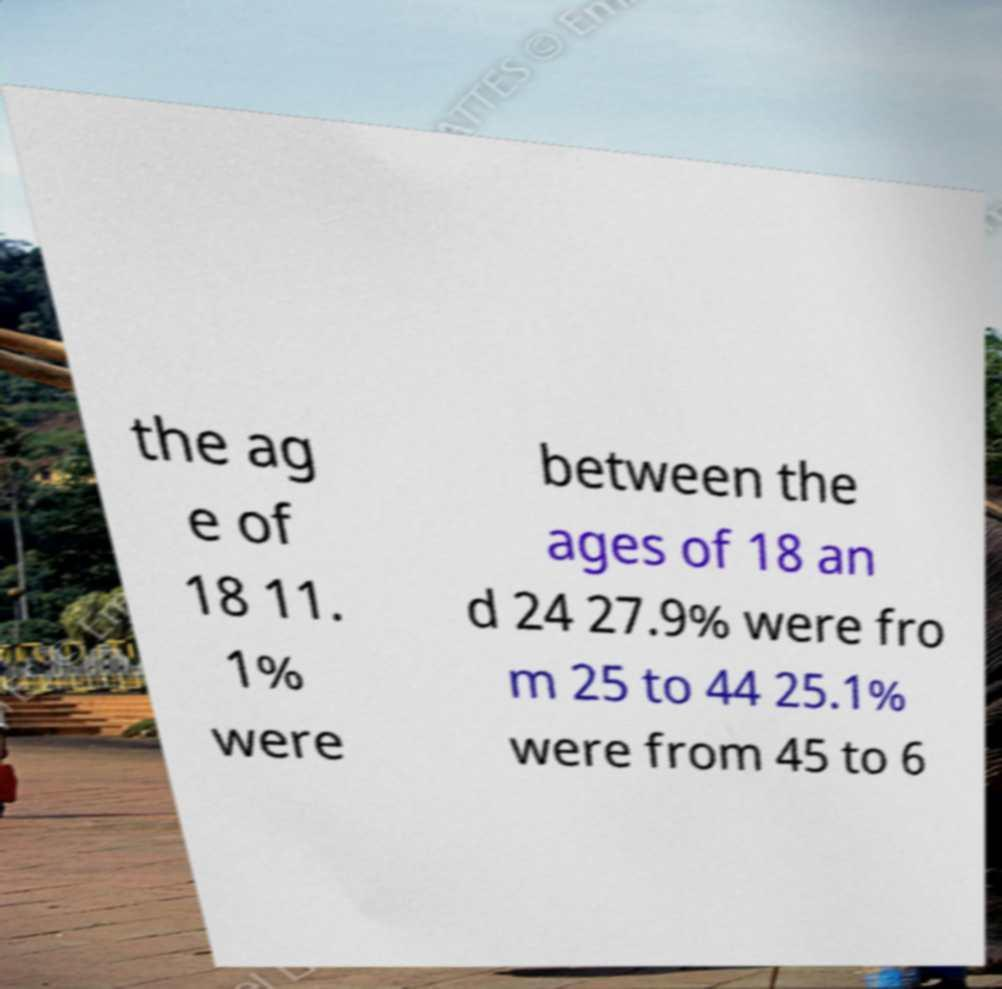What messages or text are displayed in this image? I need them in a readable, typed format. the ag e of 18 11. 1% were between the ages of 18 an d 24 27.9% were fro m 25 to 44 25.1% were from 45 to 6 